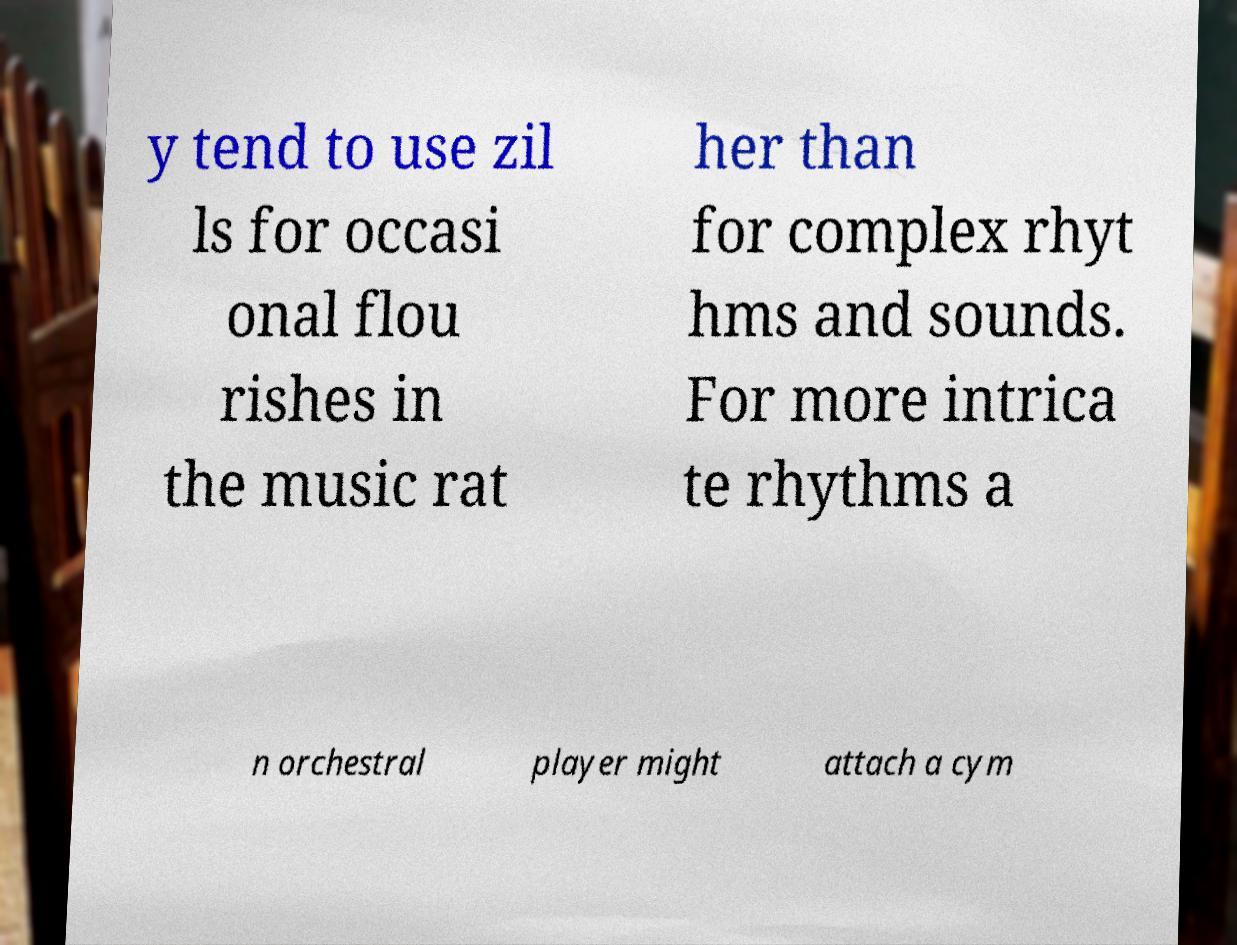Please identify and transcribe the text found in this image. y tend to use zil ls for occasi onal flou rishes in the music rat her than for complex rhyt hms and sounds. For more intrica te rhythms a n orchestral player might attach a cym 